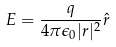Convert formula to latex. <formula><loc_0><loc_0><loc_500><loc_500>E = \frac { q } { 4 \pi \epsilon _ { 0 } | r | ^ { 2 } } \hat { r }</formula> 